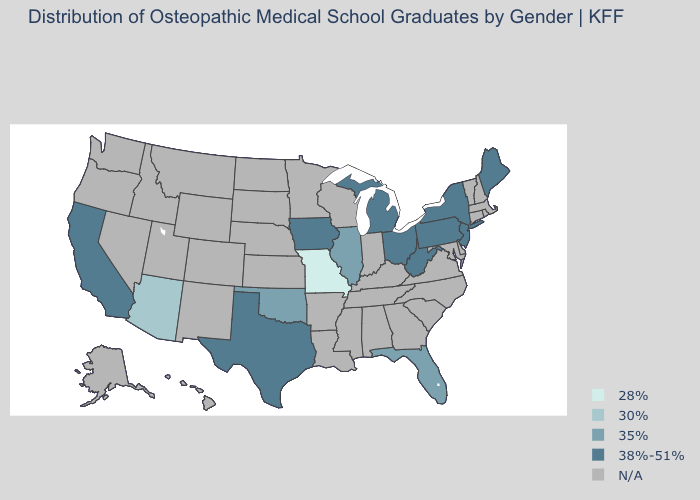What is the lowest value in the Northeast?
Short answer required. 38%-51%. Which states have the highest value in the USA?
Short answer required. California, Iowa, Maine, Michigan, New Jersey, New York, Ohio, Pennsylvania, Texas, West Virginia. What is the value of Virginia?
Be succinct. N/A. Among the states that border Kentucky , does Missouri have the lowest value?
Quick response, please. Yes. Is the legend a continuous bar?
Write a very short answer. No. What is the value of Hawaii?
Give a very brief answer. N/A. Which states have the highest value in the USA?
Write a very short answer. California, Iowa, Maine, Michigan, New Jersey, New York, Ohio, Pennsylvania, Texas, West Virginia. Does Florida have the highest value in the South?
Concise answer only. No. Name the states that have a value in the range 28%?
Quick response, please. Missouri. Does West Virginia have the highest value in the USA?
Answer briefly. Yes. Does the first symbol in the legend represent the smallest category?
Be succinct. Yes. What is the value of Vermont?
Keep it brief. N/A. What is the lowest value in states that border Nevada?
Answer briefly. 30%. Does Missouri have the lowest value in the USA?
Answer briefly. Yes. Which states hav the highest value in the West?
Keep it brief. California. 